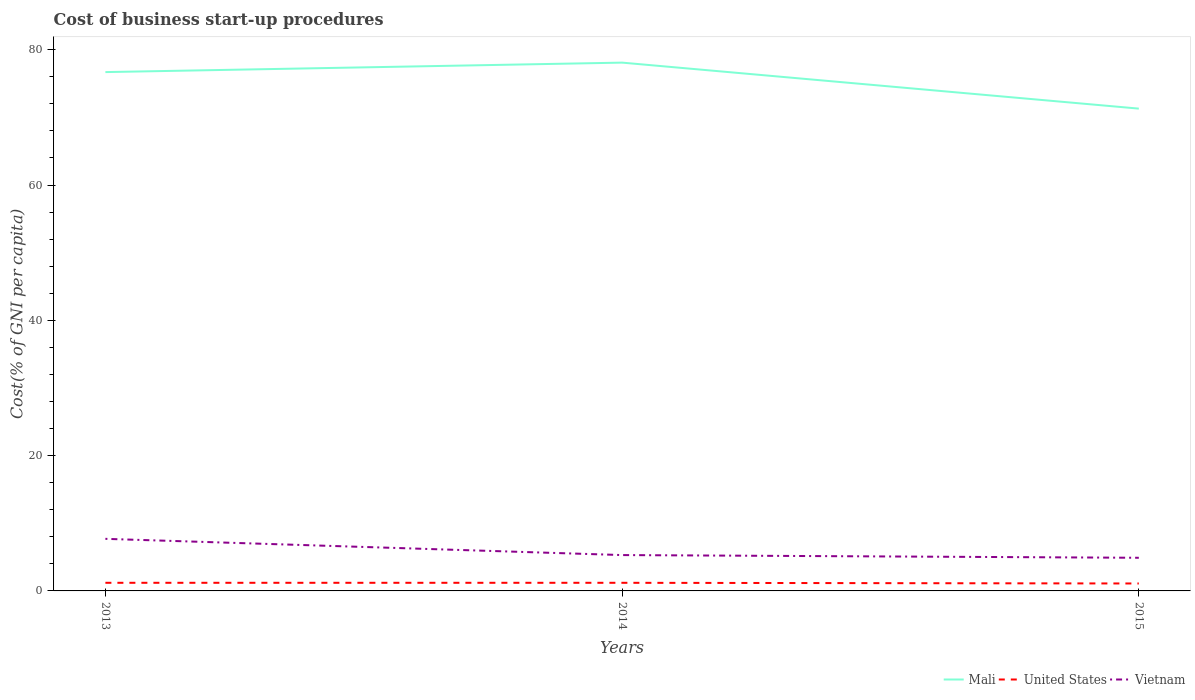How many different coloured lines are there?
Your answer should be compact. 3. Does the line corresponding to Mali intersect with the line corresponding to United States?
Give a very brief answer. No. Is the number of lines equal to the number of legend labels?
Provide a short and direct response. Yes. In which year was the cost of business start-up procedures in Mali maximum?
Your response must be concise. 2015. What is the total cost of business start-up procedures in Vietnam in the graph?
Ensure brevity in your answer.  2.8. What is the difference between the highest and the second highest cost of business start-up procedures in United States?
Provide a succinct answer. 0.1. How many lines are there?
Offer a terse response. 3. What is the difference between two consecutive major ticks on the Y-axis?
Offer a very short reply. 20. Does the graph contain any zero values?
Your response must be concise. No. Does the graph contain grids?
Your answer should be very brief. No. How many legend labels are there?
Your response must be concise. 3. How are the legend labels stacked?
Your answer should be compact. Horizontal. What is the title of the graph?
Keep it short and to the point. Cost of business start-up procedures. Does "Virgin Islands" appear as one of the legend labels in the graph?
Offer a terse response. No. What is the label or title of the Y-axis?
Keep it short and to the point. Cost(% of GNI per capita). What is the Cost(% of GNI per capita) of Mali in 2013?
Your answer should be compact. 76.7. What is the Cost(% of GNI per capita) in United States in 2013?
Offer a very short reply. 1.2. What is the Cost(% of GNI per capita) in Vietnam in 2013?
Keep it short and to the point. 7.7. What is the Cost(% of GNI per capita) in Mali in 2014?
Your answer should be very brief. 78.1. What is the Cost(% of GNI per capita) of Mali in 2015?
Make the answer very short. 71.3. Across all years, what is the maximum Cost(% of GNI per capita) in Mali?
Ensure brevity in your answer.  78.1. Across all years, what is the maximum Cost(% of GNI per capita) of United States?
Your response must be concise. 1.2. Across all years, what is the minimum Cost(% of GNI per capita) in Mali?
Your response must be concise. 71.3. What is the total Cost(% of GNI per capita) of Mali in the graph?
Keep it short and to the point. 226.1. What is the total Cost(% of GNI per capita) of United States in the graph?
Your answer should be very brief. 3.5. What is the difference between the Cost(% of GNI per capita) in United States in 2013 and that in 2014?
Offer a very short reply. 0. What is the difference between the Cost(% of GNI per capita) in Vietnam in 2013 and that in 2014?
Provide a short and direct response. 2.4. What is the difference between the Cost(% of GNI per capita) in United States in 2013 and that in 2015?
Offer a very short reply. 0.1. What is the difference between the Cost(% of GNI per capita) in Mali in 2014 and that in 2015?
Provide a succinct answer. 6.8. What is the difference between the Cost(% of GNI per capita) in United States in 2014 and that in 2015?
Give a very brief answer. 0.1. What is the difference between the Cost(% of GNI per capita) in Mali in 2013 and the Cost(% of GNI per capita) in United States in 2014?
Your answer should be very brief. 75.5. What is the difference between the Cost(% of GNI per capita) in Mali in 2013 and the Cost(% of GNI per capita) in Vietnam in 2014?
Provide a short and direct response. 71.4. What is the difference between the Cost(% of GNI per capita) in Mali in 2013 and the Cost(% of GNI per capita) in United States in 2015?
Your answer should be very brief. 75.6. What is the difference between the Cost(% of GNI per capita) of Mali in 2013 and the Cost(% of GNI per capita) of Vietnam in 2015?
Ensure brevity in your answer.  71.8. What is the difference between the Cost(% of GNI per capita) in Mali in 2014 and the Cost(% of GNI per capita) in Vietnam in 2015?
Your response must be concise. 73.2. What is the average Cost(% of GNI per capita) in Mali per year?
Keep it short and to the point. 75.37. What is the average Cost(% of GNI per capita) in United States per year?
Your answer should be compact. 1.17. What is the average Cost(% of GNI per capita) of Vietnam per year?
Your answer should be compact. 5.97. In the year 2013, what is the difference between the Cost(% of GNI per capita) of Mali and Cost(% of GNI per capita) of United States?
Offer a terse response. 75.5. In the year 2014, what is the difference between the Cost(% of GNI per capita) of Mali and Cost(% of GNI per capita) of United States?
Provide a short and direct response. 76.9. In the year 2014, what is the difference between the Cost(% of GNI per capita) of Mali and Cost(% of GNI per capita) of Vietnam?
Provide a succinct answer. 72.8. In the year 2014, what is the difference between the Cost(% of GNI per capita) of United States and Cost(% of GNI per capita) of Vietnam?
Your answer should be very brief. -4.1. In the year 2015, what is the difference between the Cost(% of GNI per capita) of Mali and Cost(% of GNI per capita) of United States?
Your response must be concise. 70.2. In the year 2015, what is the difference between the Cost(% of GNI per capita) of Mali and Cost(% of GNI per capita) of Vietnam?
Provide a succinct answer. 66.4. In the year 2015, what is the difference between the Cost(% of GNI per capita) of United States and Cost(% of GNI per capita) of Vietnam?
Make the answer very short. -3.8. What is the ratio of the Cost(% of GNI per capita) of Mali in 2013 to that in 2014?
Give a very brief answer. 0.98. What is the ratio of the Cost(% of GNI per capita) in Vietnam in 2013 to that in 2014?
Offer a terse response. 1.45. What is the ratio of the Cost(% of GNI per capita) in Mali in 2013 to that in 2015?
Offer a terse response. 1.08. What is the ratio of the Cost(% of GNI per capita) of United States in 2013 to that in 2015?
Keep it short and to the point. 1.09. What is the ratio of the Cost(% of GNI per capita) in Vietnam in 2013 to that in 2015?
Ensure brevity in your answer.  1.57. What is the ratio of the Cost(% of GNI per capita) in Mali in 2014 to that in 2015?
Your answer should be compact. 1.1. What is the ratio of the Cost(% of GNI per capita) in Vietnam in 2014 to that in 2015?
Provide a succinct answer. 1.08. What is the difference between the highest and the lowest Cost(% of GNI per capita) of Mali?
Your response must be concise. 6.8. What is the difference between the highest and the lowest Cost(% of GNI per capita) in United States?
Provide a succinct answer. 0.1. 